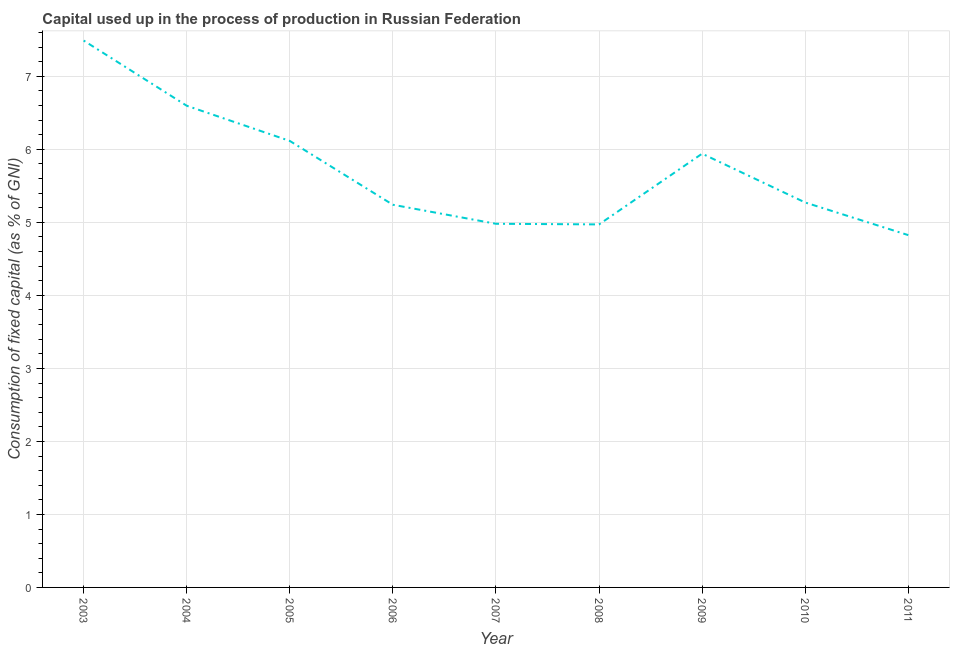What is the consumption of fixed capital in 2003?
Your response must be concise. 7.49. Across all years, what is the maximum consumption of fixed capital?
Give a very brief answer. 7.49. Across all years, what is the minimum consumption of fixed capital?
Your answer should be very brief. 4.83. In which year was the consumption of fixed capital minimum?
Ensure brevity in your answer.  2011. What is the sum of the consumption of fixed capital?
Offer a very short reply. 51.44. What is the difference between the consumption of fixed capital in 2008 and 2011?
Provide a short and direct response. 0.15. What is the average consumption of fixed capital per year?
Provide a short and direct response. 5.72. What is the median consumption of fixed capital?
Your response must be concise. 5.27. In how many years, is the consumption of fixed capital greater than 3.4 %?
Your answer should be compact. 9. What is the ratio of the consumption of fixed capital in 2007 to that in 2009?
Make the answer very short. 0.84. Is the consumption of fixed capital in 2004 less than that in 2005?
Your answer should be very brief. No. Is the difference between the consumption of fixed capital in 2010 and 2011 greater than the difference between any two years?
Your response must be concise. No. What is the difference between the highest and the second highest consumption of fixed capital?
Keep it short and to the point. 0.89. What is the difference between the highest and the lowest consumption of fixed capital?
Offer a very short reply. 2.66. Does the consumption of fixed capital monotonically increase over the years?
Give a very brief answer. No. What is the difference between two consecutive major ticks on the Y-axis?
Ensure brevity in your answer.  1. Does the graph contain any zero values?
Your answer should be very brief. No. What is the title of the graph?
Make the answer very short. Capital used up in the process of production in Russian Federation. What is the label or title of the Y-axis?
Your response must be concise. Consumption of fixed capital (as % of GNI). What is the Consumption of fixed capital (as % of GNI) of 2003?
Offer a terse response. 7.49. What is the Consumption of fixed capital (as % of GNI) of 2004?
Offer a very short reply. 6.6. What is the Consumption of fixed capital (as % of GNI) of 2005?
Give a very brief answer. 6.12. What is the Consumption of fixed capital (as % of GNI) of 2006?
Provide a short and direct response. 5.24. What is the Consumption of fixed capital (as % of GNI) of 2007?
Your answer should be compact. 4.98. What is the Consumption of fixed capital (as % of GNI) of 2008?
Keep it short and to the point. 4.97. What is the Consumption of fixed capital (as % of GNI) of 2009?
Ensure brevity in your answer.  5.94. What is the Consumption of fixed capital (as % of GNI) in 2010?
Your response must be concise. 5.27. What is the Consumption of fixed capital (as % of GNI) of 2011?
Provide a short and direct response. 4.83. What is the difference between the Consumption of fixed capital (as % of GNI) in 2003 and 2004?
Ensure brevity in your answer.  0.89. What is the difference between the Consumption of fixed capital (as % of GNI) in 2003 and 2005?
Offer a terse response. 1.37. What is the difference between the Consumption of fixed capital (as % of GNI) in 2003 and 2006?
Give a very brief answer. 2.25. What is the difference between the Consumption of fixed capital (as % of GNI) in 2003 and 2007?
Give a very brief answer. 2.51. What is the difference between the Consumption of fixed capital (as % of GNI) in 2003 and 2008?
Make the answer very short. 2.52. What is the difference between the Consumption of fixed capital (as % of GNI) in 2003 and 2009?
Make the answer very short. 1.55. What is the difference between the Consumption of fixed capital (as % of GNI) in 2003 and 2010?
Make the answer very short. 2.22. What is the difference between the Consumption of fixed capital (as % of GNI) in 2003 and 2011?
Your response must be concise. 2.66. What is the difference between the Consumption of fixed capital (as % of GNI) in 2004 and 2005?
Provide a succinct answer. 0.48. What is the difference between the Consumption of fixed capital (as % of GNI) in 2004 and 2006?
Provide a short and direct response. 1.36. What is the difference between the Consumption of fixed capital (as % of GNI) in 2004 and 2007?
Offer a very short reply. 1.62. What is the difference between the Consumption of fixed capital (as % of GNI) in 2004 and 2008?
Your answer should be compact. 1.63. What is the difference between the Consumption of fixed capital (as % of GNI) in 2004 and 2009?
Provide a succinct answer. 0.66. What is the difference between the Consumption of fixed capital (as % of GNI) in 2004 and 2010?
Ensure brevity in your answer.  1.33. What is the difference between the Consumption of fixed capital (as % of GNI) in 2004 and 2011?
Your response must be concise. 1.77. What is the difference between the Consumption of fixed capital (as % of GNI) in 2005 and 2006?
Keep it short and to the point. 0.87. What is the difference between the Consumption of fixed capital (as % of GNI) in 2005 and 2007?
Make the answer very short. 1.13. What is the difference between the Consumption of fixed capital (as % of GNI) in 2005 and 2008?
Ensure brevity in your answer.  1.14. What is the difference between the Consumption of fixed capital (as % of GNI) in 2005 and 2009?
Your response must be concise. 0.17. What is the difference between the Consumption of fixed capital (as % of GNI) in 2005 and 2010?
Provide a short and direct response. 0.84. What is the difference between the Consumption of fixed capital (as % of GNI) in 2005 and 2011?
Ensure brevity in your answer.  1.29. What is the difference between the Consumption of fixed capital (as % of GNI) in 2006 and 2007?
Offer a terse response. 0.26. What is the difference between the Consumption of fixed capital (as % of GNI) in 2006 and 2008?
Make the answer very short. 0.27. What is the difference between the Consumption of fixed capital (as % of GNI) in 2006 and 2009?
Give a very brief answer. -0.7. What is the difference between the Consumption of fixed capital (as % of GNI) in 2006 and 2010?
Give a very brief answer. -0.03. What is the difference between the Consumption of fixed capital (as % of GNI) in 2006 and 2011?
Your answer should be compact. 0.42. What is the difference between the Consumption of fixed capital (as % of GNI) in 2007 and 2008?
Your response must be concise. 0.01. What is the difference between the Consumption of fixed capital (as % of GNI) in 2007 and 2009?
Offer a very short reply. -0.96. What is the difference between the Consumption of fixed capital (as % of GNI) in 2007 and 2010?
Keep it short and to the point. -0.29. What is the difference between the Consumption of fixed capital (as % of GNI) in 2007 and 2011?
Keep it short and to the point. 0.16. What is the difference between the Consumption of fixed capital (as % of GNI) in 2008 and 2009?
Your answer should be very brief. -0.97. What is the difference between the Consumption of fixed capital (as % of GNI) in 2008 and 2010?
Your response must be concise. -0.3. What is the difference between the Consumption of fixed capital (as % of GNI) in 2008 and 2011?
Give a very brief answer. 0.15. What is the difference between the Consumption of fixed capital (as % of GNI) in 2009 and 2010?
Ensure brevity in your answer.  0.67. What is the difference between the Consumption of fixed capital (as % of GNI) in 2009 and 2011?
Offer a very short reply. 1.12. What is the difference between the Consumption of fixed capital (as % of GNI) in 2010 and 2011?
Your answer should be very brief. 0.45. What is the ratio of the Consumption of fixed capital (as % of GNI) in 2003 to that in 2004?
Your answer should be compact. 1.14. What is the ratio of the Consumption of fixed capital (as % of GNI) in 2003 to that in 2005?
Offer a very short reply. 1.23. What is the ratio of the Consumption of fixed capital (as % of GNI) in 2003 to that in 2006?
Offer a terse response. 1.43. What is the ratio of the Consumption of fixed capital (as % of GNI) in 2003 to that in 2007?
Offer a terse response. 1.5. What is the ratio of the Consumption of fixed capital (as % of GNI) in 2003 to that in 2008?
Provide a succinct answer. 1.51. What is the ratio of the Consumption of fixed capital (as % of GNI) in 2003 to that in 2009?
Make the answer very short. 1.26. What is the ratio of the Consumption of fixed capital (as % of GNI) in 2003 to that in 2010?
Ensure brevity in your answer.  1.42. What is the ratio of the Consumption of fixed capital (as % of GNI) in 2003 to that in 2011?
Your response must be concise. 1.55. What is the ratio of the Consumption of fixed capital (as % of GNI) in 2004 to that in 2005?
Keep it short and to the point. 1.08. What is the ratio of the Consumption of fixed capital (as % of GNI) in 2004 to that in 2006?
Offer a terse response. 1.26. What is the ratio of the Consumption of fixed capital (as % of GNI) in 2004 to that in 2007?
Offer a very short reply. 1.32. What is the ratio of the Consumption of fixed capital (as % of GNI) in 2004 to that in 2008?
Ensure brevity in your answer.  1.33. What is the ratio of the Consumption of fixed capital (as % of GNI) in 2004 to that in 2009?
Provide a short and direct response. 1.11. What is the ratio of the Consumption of fixed capital (as % of GNI) in 2004 to that in 2010?
Make the answer very short. 1.25. What is the ratio of the Consumption of fixed capital (as % of GNI) in 2004 to that in 2011?
Make the answer very short. 1.37. What is the ratio of the Consumption of fixed capital (as % of GNI) in 2005 to that in 2006?
Your answer should be very brief. 1.17. What is the ratio of the Consumption of fixed capital (as % of GNI) in 2005 to that in 2007?
Ensure brevity in your answer.  1.23. What is the ratio of the Consumption of fixed capital (as % of GNI) in 2005 to that in 2008?
Give a very brief answer. 1.23. What is the ratio of the Consumption of fixed capital (as % of GNI) in 2005 to that in 2010?
Make the answer very short. 1.16. What is the ratio of the Consumption of fixed capital (as % of GNI) in 2005 to that in 2011?
Keep it short and to the point. 1.27. What is the ratio of the Consumption of fixed capital (as % of GNI) in 2006 to that in 2007?
Give a very brief answer. 1.05. What is the ratio of the Consumption of fixed capital (as % of GNI) in 2006 to that in 2008?
Make the answer very short. 1.05. What is the ratio of the Consumption of fixed capital (as % of GNI) in 2006 to that in 2009?
Ensure brevity in your answer.  0.88. What is the ratio of the Consumption of fixed capital (as % of GNI) in 2006 to that in 2010?
Offer a terse response. 0.99. What is the ratio of the Consumption of fixed capital (as % of GNI) in 2006 to that in 2011?
Provide a short and direct response. 1.09. What is the ratio of the Consumption of fixed capital (as % of GNI) in 2007 to that in 2008?
Ensure brevity in your answer.  1. What is the ratio of the Consumption of fixed capital (as % of GNI) in 2007 to that in 2009?
Offer a very short reply. 0.84. What is the ratio of the Consumption of fixed capital (as % of GNI) in 2007 to that in 2010?
Provide a short and direct response. 0.94. What is the ratio of the Consumption of fixed capital (as % of GNI) in 2007 to that in 2011?
Your response must be concise. 1.03. What is the ratio of the Consumption of fixed capital (as % of GNI) in 2008 to that in 2009?
Ensure brevity in your answer.  0.84. What is the ratio of the Consumption of fixed capital (as % of GNI) in 2008 to that in 2010?
Offer a terse response. 0.94. What is the ratio of the Consumption of fixed capital (as % of GNI) in 2008 to that in 2011?
Provide a succinct answer. 1.03. What is the ratio of the Consumption of fixed capital (as % of GNI) in 2009 to that in 2010?
Make the answer very short. 1.13. What is the ratio of the Consumption of fixed capital (as % of GNI) in 2009 to that in 2011?
Your response must be concise. 1.23. What is the ratio of the Consumption of fixed capital (as % of GNI) in 2010 to that in 2011?
Your response must be concise. 1.09. 